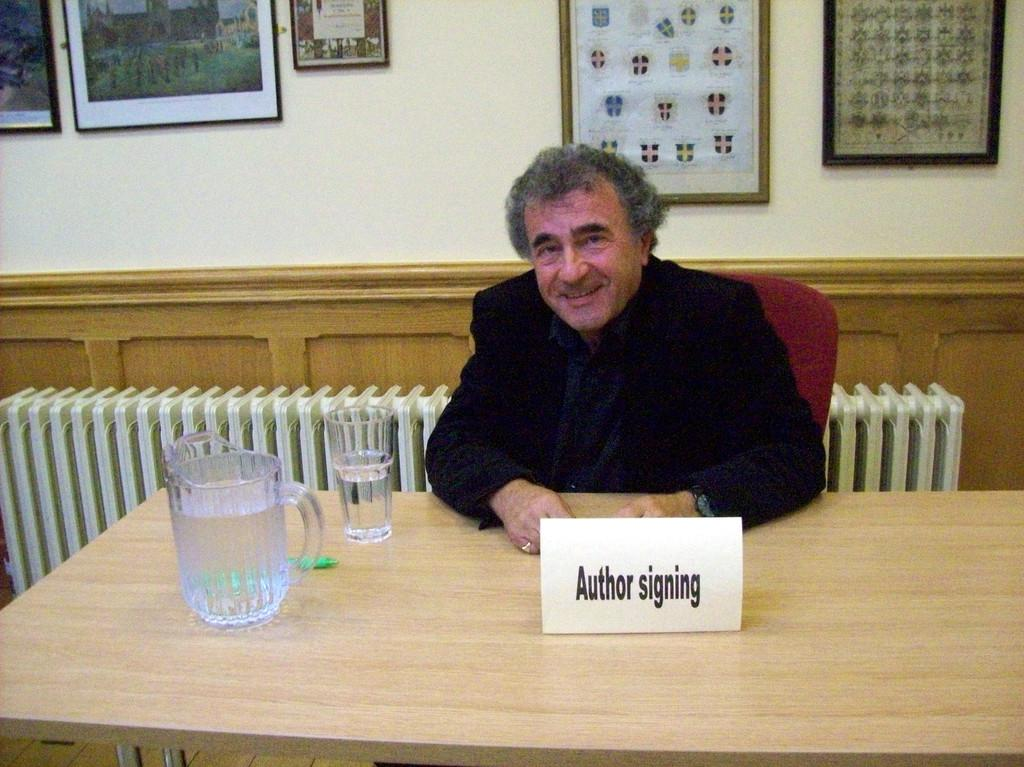What is the man in the image doing? The man is sitting on a chair in the image. What expression does the man have? The man is smiling. What is on the table in front of the man? There is a glass and a mug on the table. What can be seen on the wall in the background of the image? There is a photo frame on the wall. What type of powder is visible on the cushion in the image? There is no cushion present in the image, and therefore no powder can be observed. 